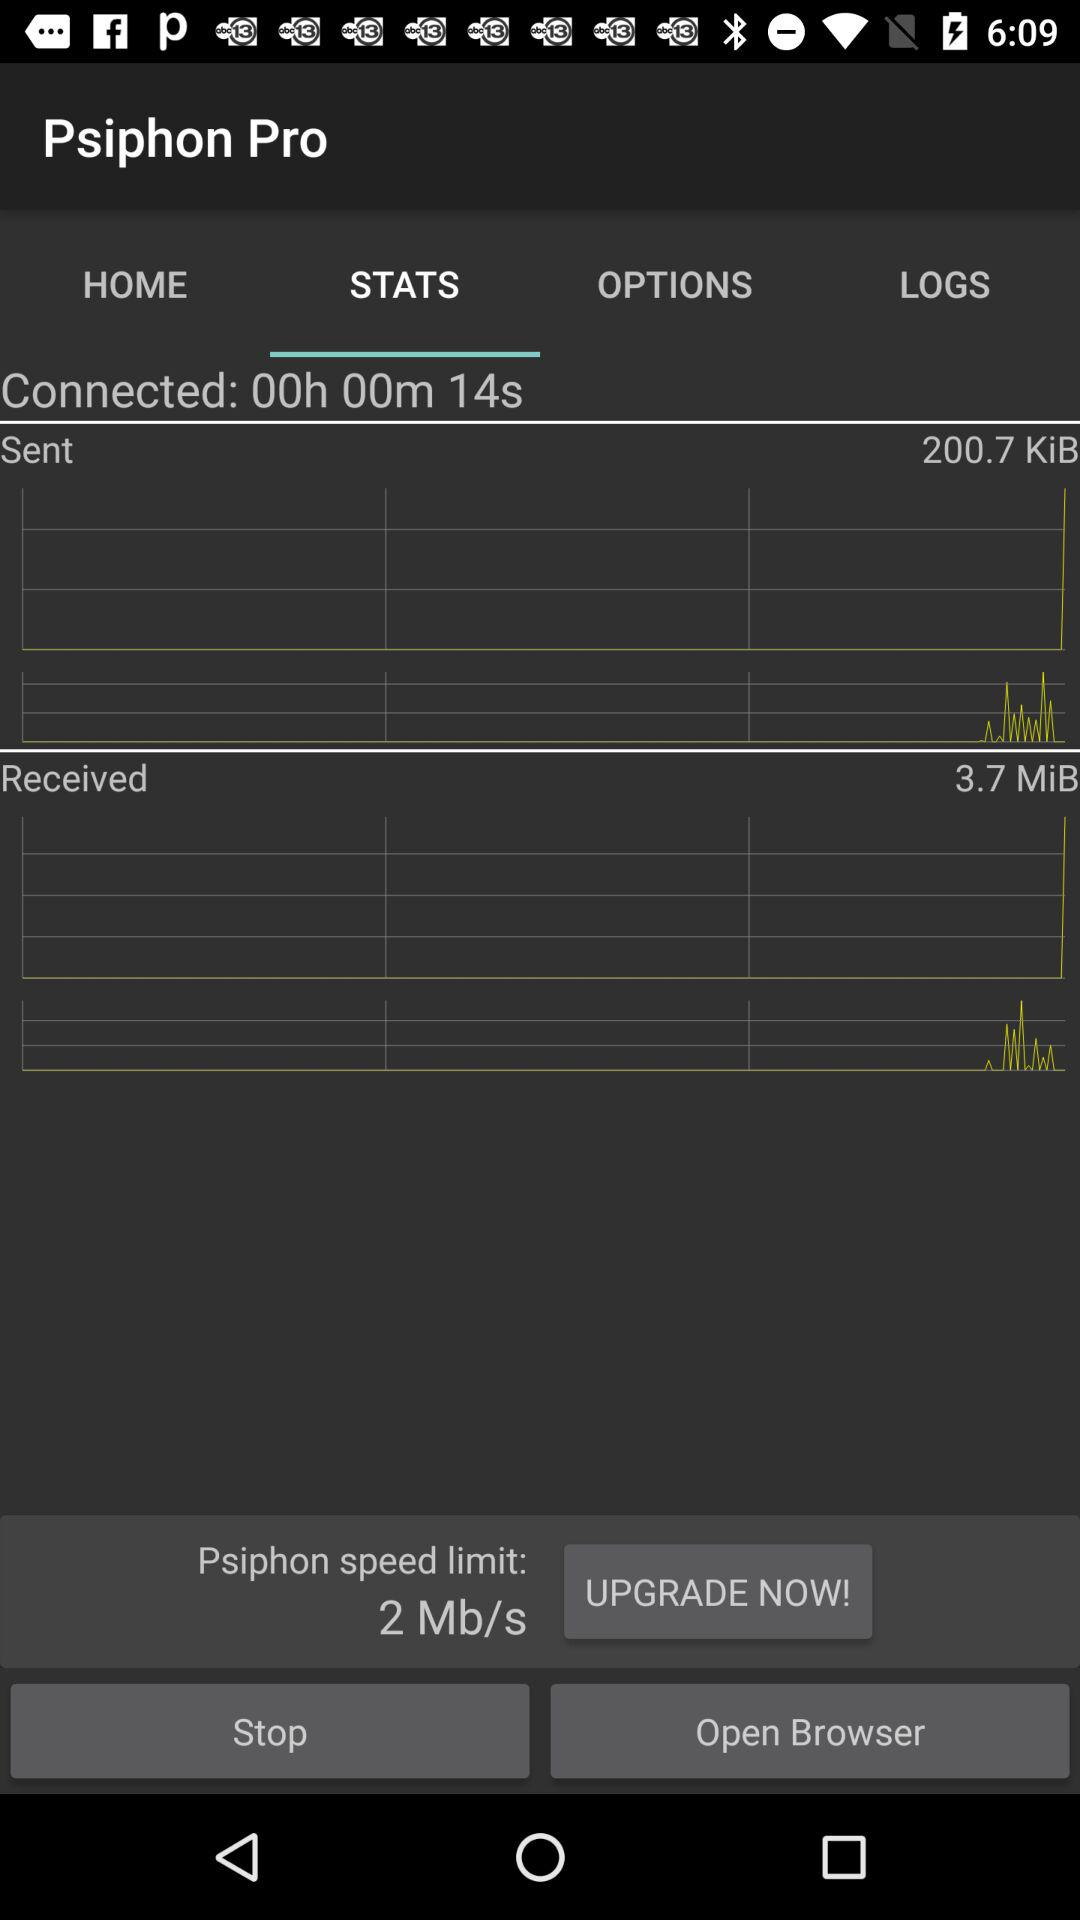How much data is received? The received data is 3.7 MiB. 